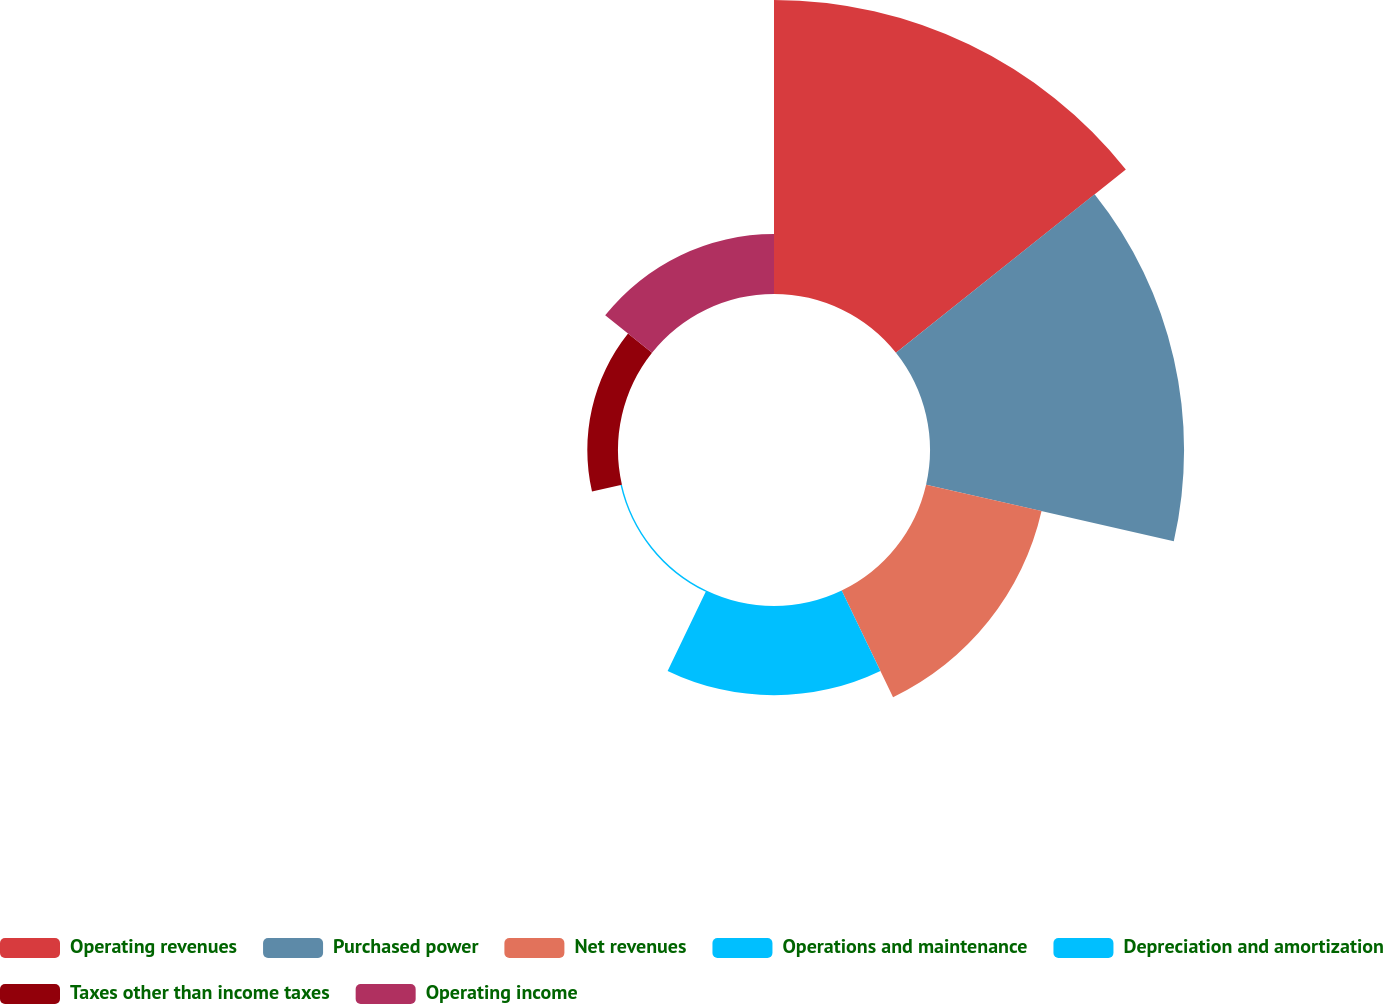Convert chart to OTSL. <chart><loc_0><loc_0><loc_500><loc_500><pie_chart><fcel>Operating revenues<fcel>Purchased power<fcel>Net revenues<fcel>Operations and maintenance<fcel>Depreciation and amortization<fcel>Taxes other than income taxes<fcel>Operating income<nl><fcel>34.68%<fcel>29.97%<fcel>13.97%<fcel>10.52%<fcel>0.17%<fcel>3.62%<fcel>7.07%<nl></chart> 